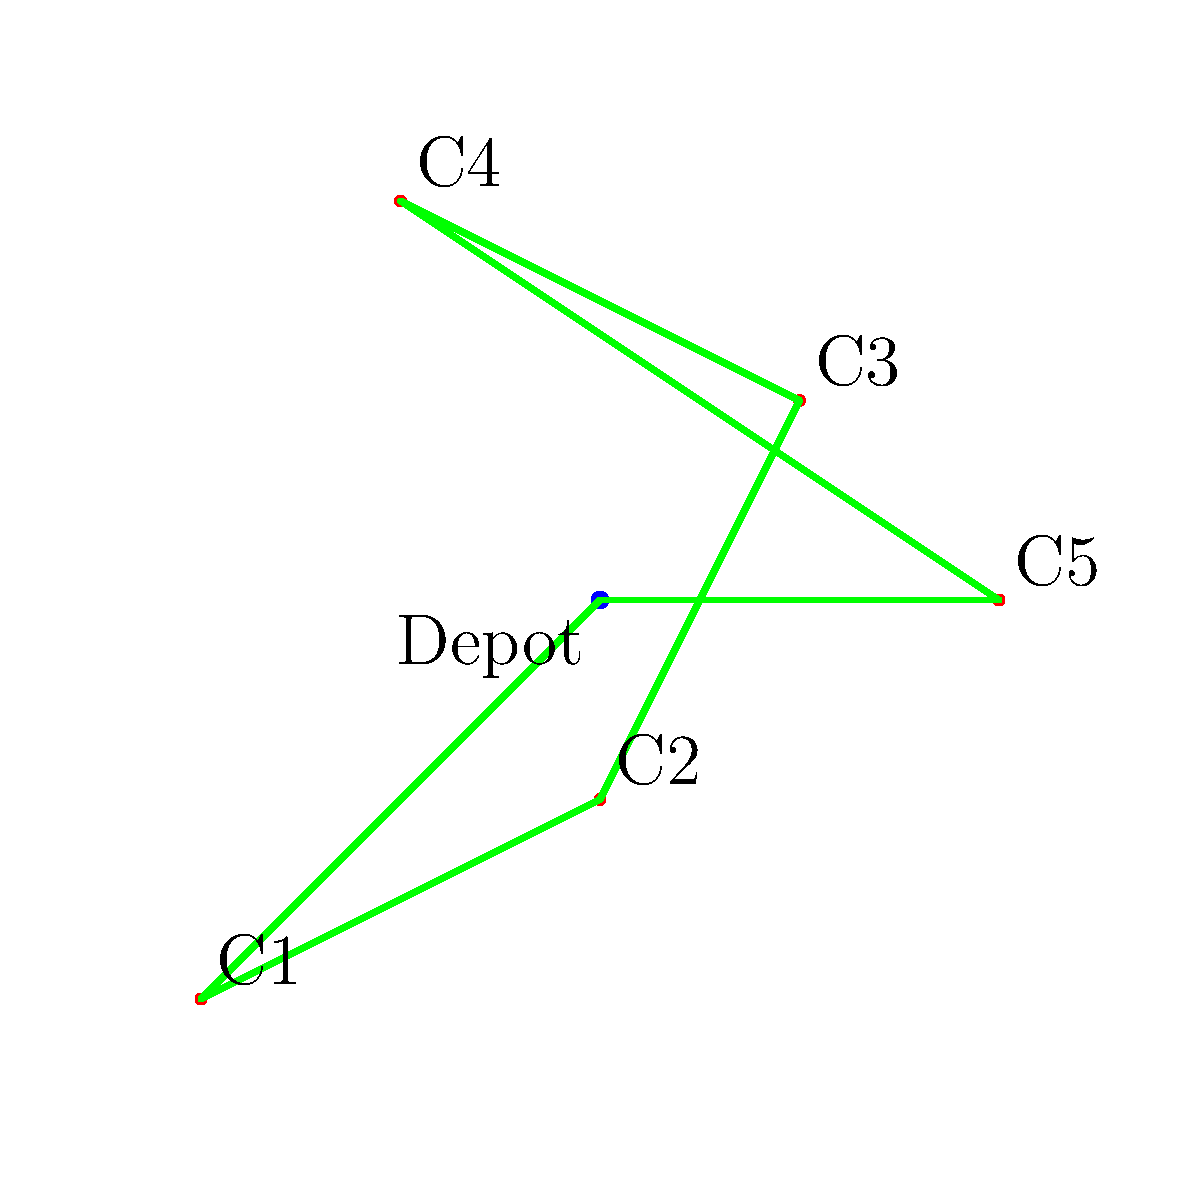As a delivery driver, you're tasked with finding the most efficient route to deliver packages to 5 customers. Given the map above showing customer locations (C1 to C5) and the depot, which sequence of visits would likely be the most efficient route, assuming you start and end at the depot? To determine the most efficient route, we'll use the nearest neighbor algorithm, a simple heuristic for the Traveling Salesman Problem. Here's the step-by-step process:

1. Start at the depot (2,2).
2. Find the nearest unvisited customer:
   - C1 (0,0): distance = $\sqrt{(2-0)^2 + (2-0)^2} = 2.83$
   - C2 (2,1): distance = $\sqrt{(2-2)^2 + (2-1)^2} = 1$
   - C3 (3,3): distance = $\sqrt{(2-3)^2 + (2-3)^2} = 1.41$
   - C4 (1,4): distance = $\sqrt{(2-1)^2 + (2-4)^2} = 2.24$
   - C5 (4,2): distance = $\sqrt{(2-4)^2 + (2-2)^2} = 2$
   C2 is closest, so visit C2 first.

3. From C2, find the nearest unvisited customer:
   - C1: distance = 2.24
   - C3: distance = 2.24
   - C4: distance = 3.16
   - C5: distance = 2.24
   C1, C3, and C5 are equidistant. Let's choose C5 arbitrarily.

4. From C5, the nearest unvisited customer is C3 (distance = 1.41).

5. From C3, the nearest unvisited customer is C4 (distance = 2.24).

6. Visit the last customer, C1.

7. Return to the depot.

The resulting route is: Depot -> C2 -> C5 -> C3 -> C4 -> C1 -> Depot
Answer: Depot -> C2 -> C5 -> C3 -> C4 -> C1 -> Depot 